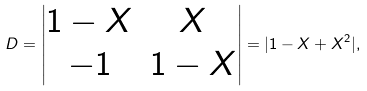<formula> <loc_0><loc_0><loc_500><loc_500>D = \begin{vmatrix} 1 - X & X \\ - 1 & 1 - X \end{vmatrix} = | 1 - X + X ^ { 2 } | ,</formula> 